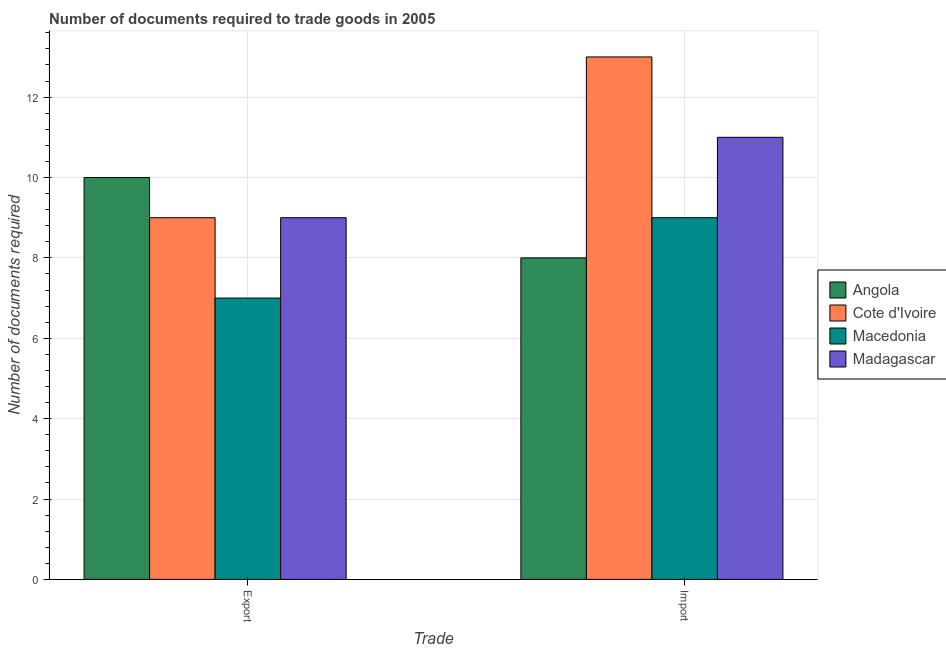How many different coloured bars are there?
Offer a very short reply. 4. How many bars are there on the 1st tick from the left?
Ensure brevity in your answer.  4. How many bars are there on the 2nd tick from the right?
Your answer should be compact. 4. What is the label of the 1st group of bars from the left?
Ensure brevity in your answer.  Export. What is the number of documents required to import goods in Macedonia?
Offer a very short reply. 9. Across all countries, what is the maximum number of documents required to export goods?
Offer a very short reply. 10. Across all countries, what is the minimum number of documents required to import goods?
Keep it short and to the point. 8. In which country was the number of documents required to export goods maximum?
Offer a terse response. Angola. In which country was the number of documents required to import goods minimum?
Give a very brief answer. Angola. What is the total number of documents required to export goods in the graph?
Provide a short and direct response. 35. What is the difference between the number of documents required to export goods in Madagascar and that in Angola?
Keep it short and to the point. -1. What is the difference between the number of documents required to import goods in Angola and the number of documents required to export goods in Macedonia?
Provide a short and direct response. 1. What is the average number of documents required to export goods per country?
Ensure brevity in your answer.  8.75. What is the difference between the number of documents required to import goods and number of documents required to export goods in Cote d'Ivoire?
Your response must be concise. 4. In how many countries, is the number of documents required to import goods greater than 11.6 ?
Ensure brevity in your answer.  1. Is the number of documents required to import goods in Macedonia less than that in Cote d'Ivoire?
Your response must be concise. Yes. In how many countries, is the number of documents required to export goods greater than the average number of documents required to export goods taken over all countries?
Provide a succinct answer. 3. What does the 1st bar from the left in Import represents?
Your response must be concise. Angola. What does the 4th bar from the right in Import represents?
Make the answer very short. Angola. How many bars are there?
Make the answer very short. 8. Are the values on the major ticks of Y-axis written in scientific E-notation?
Offer a terse response. No. Does the graph contain grids?
Your answer should be compact. Yes. Where does the legend appear in the graph?
Keep it short and to the point. Center right. How many legend labels are there?
Your answer should be very brief. 4. How are the legend labels stacked?
Your answer should be compact. Vertical. What is the title of the graph?
Your response must be concise. Number of documents required to trade goods in 2005. What is the label or title of the X-axis?
Give a very brief answer. Trade. What is the label or title of the Y-axis?
Provide a succinct answer. Number of documents required. What is the Number of documents required in Angola in Export?
Provide a succinct answer. 10. What is the Number of documents required in Macedonia in Import?
Your answer should be very brief. 9. What is the Number of documents required of Madagascar in Import?
Offer a very short reply. 11. Across all Trade, what is the maximum Number of documents required in Angola?
Offer a terse response. 10. Across all Trade, what is the maximum Number of documents required in Macedonia?
Provide a short and direct response. 9. Across all Trade, what is the maximum Number of documents required of Madagascar?
Keep it short and to the point. 11. Across all Trade, what is the minimum Number of documents required in Cote d'Ivoire?
Your answer should be compact. 9. Across all Trade, what is the minimum Number of documents required in Macedonia?
Provide a succinct answer. 7. Across all Trade, what is the minimum Number of documents required of Madagascar?
Keep it short and to the point. 9. What is the total Number of documents required of Cote d'Ivoire in the graph?
Give a very brief answer. 22. What is the total Number of documents required of Macedonia in the graph?
Your answer should be compact. 16. What is the total Number of documents required in Madagascar in the graph?
Keep it short and to the point. 20. What is the difference between the Number of documents required in Angola in Export and that in Import?
Keep it short and to the point. 2. What is the difference between the Number of documents required of Cote d'Ivoire in Export and that in Import?
Your response must be concise. -4. What is the difference between the Number of documents required in Angola in Export and the Number of documents required in Cote d'Ivoire in Import?
Provide a succinct answer. -3. What is the difference between the Number of documents required of Angola in Export and the Number of documents required of Madagascar in Import?
Offer a very short reply. -1. What is the difference between the Number of documents required of Cote d'Ivoire in Export and the Number of documents required of Madagascar in Import?
Your response must be concise. -2. What is the average Number of documents required of Angola per Trade?
Your answer should be compact. 9. What is the average Number of documents required in Cote d'Ivoire per Trade?
Give a very brief answer. 11. What is the difference between the Number of documents required of Angola and Number of documents required of Cote d'Ivoire in Export?
Your response must be concise. 1. What is the difference between the Number of documents required in Angola and Number of documents required in Madagascar in Export?
Give a very brief answer. 1. What is the difference between the Number of documents required in Cote d'Ivoire and Number of documents required in Macedonia in Export?
Your answer should be compact. 2. What is the difference between the Number of documents required in Cote d'Ivoire and Number of documents required in Madagascar in Export?
Offer a terse response. 0. What is the difference between the Number of documents required of Macedonia and Number of documents required of Madagascar in Export?
Keep it short and to the point. -2. What is the difference between the Number of documents required of Angola and Number of documents required of Madagascar in Import?
Your answer should be compact. -3. What is the difference between the Number of documents required of Cote d'Ivoire and Number of documents required of Macedonia in Import?
Your response must be concise. 4. What is the difference between the Number of documents required in Macedonia and Number of documents required in Madagascar in Import?
Ensure brevity in your answer.  -2. What is the ratio of the Number of documents required in Cote d'Ivoire in Export to that in Import?
Your answer should be compact. 0.69. What is the ratio of the Number of documents required in Madagascar in Export to that in Import?
Provide a succinct answer. 0.82. What is the difference between the highest and the second highest Number of documents required in Angola?
Keep it short and to the point. 2. What is the difference between the highest and the second highest Number of documents required of Madagascar?
Offer a terse response. 2. What is the difference between the highest and the lowest Number of documents required in Angola?
Make the answer very short. 2. What is the difference between the highest and the lowest Number of documents required of Cote d'Ivoire?
Provide a succinct answer. 4. 